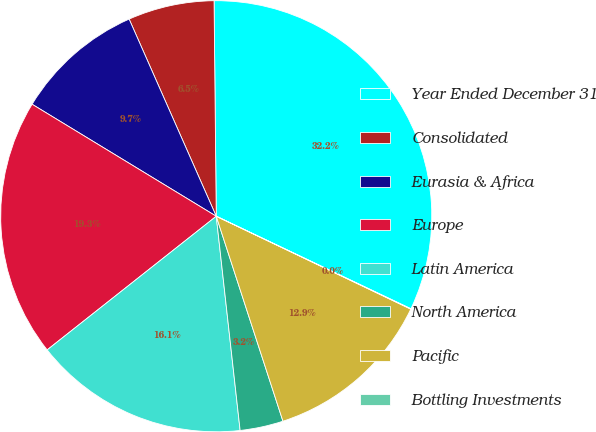Convert chart. <chart><loc_0><loc_0><loc_500><loc_500><pie_chart><fcel>Year Ended December 31<fcel>Consolidated<fcel>Eurasia & Africa<fcel>Europe<fcel>Latin America<fcel>North America<fcel>Pacific<fcel>Bottling Investments<nl><fcel>32.22%<fcel>6.46%<fcel>9.68%<fcel>19.34%<fcel>16.12%<fcel>3.24%<fcel>12.9%<fcel>0.03%<nl></chart> 